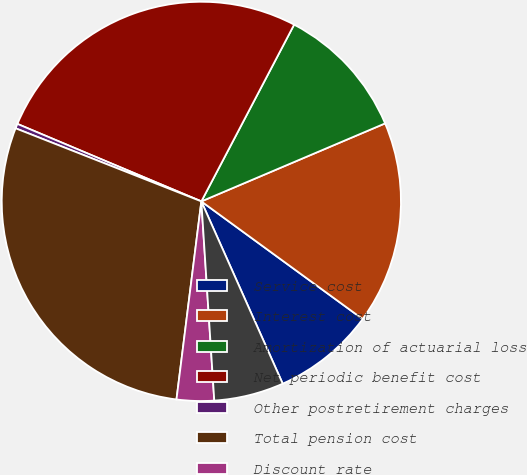Convert chart. <chart><loc_0><loc_0><loc_500><loc_500><pie_chart><fcel>Service cost<fcel>Interest cost<fcel>Amortization of actuarial loss<fcel>Net periodic benefit cost<fcel>Other postretirement charges<fcel>Total pension cost<fcel>Discount rate<fcel>Long-term rate of return on<nl><fcel>8.29%<fcel>16.42%<fcel>10.92%<fcel>26.35%<fcel>0.38%<fcel>28.98%<fcel>3.02%<fcel>5.65%<nl></chart> 